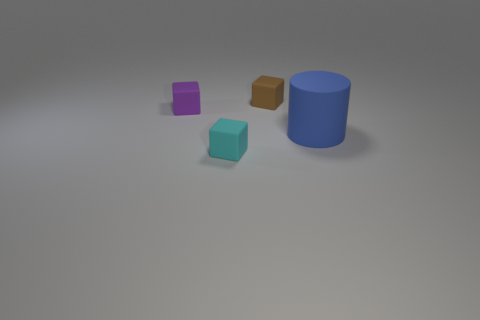Subtract all small purple blocks. How many blocks are left? 2 Subtract all cylinders. How many objects are left? 3 Subtract 1 cylinders. How many cylinders are left? 0 Subtract all green cylinders. Subtract all green balls. How many cylinders are left? 1 Subtract all brown cubes. How many cyan cylinders are left? 0 Subtract all blue matte cylinders. Subtract all cyan rubber things. How many objects are left? 2 Add 2 small cyan things. How many small cyan things are left? 3 Add 3 small brown matte things. How many small brown matte things exist? 4 Add 2 tiny yellow metallic blocks. How many objects exist? 6 Subtract all brown cubes. How many cubes are left? 2 